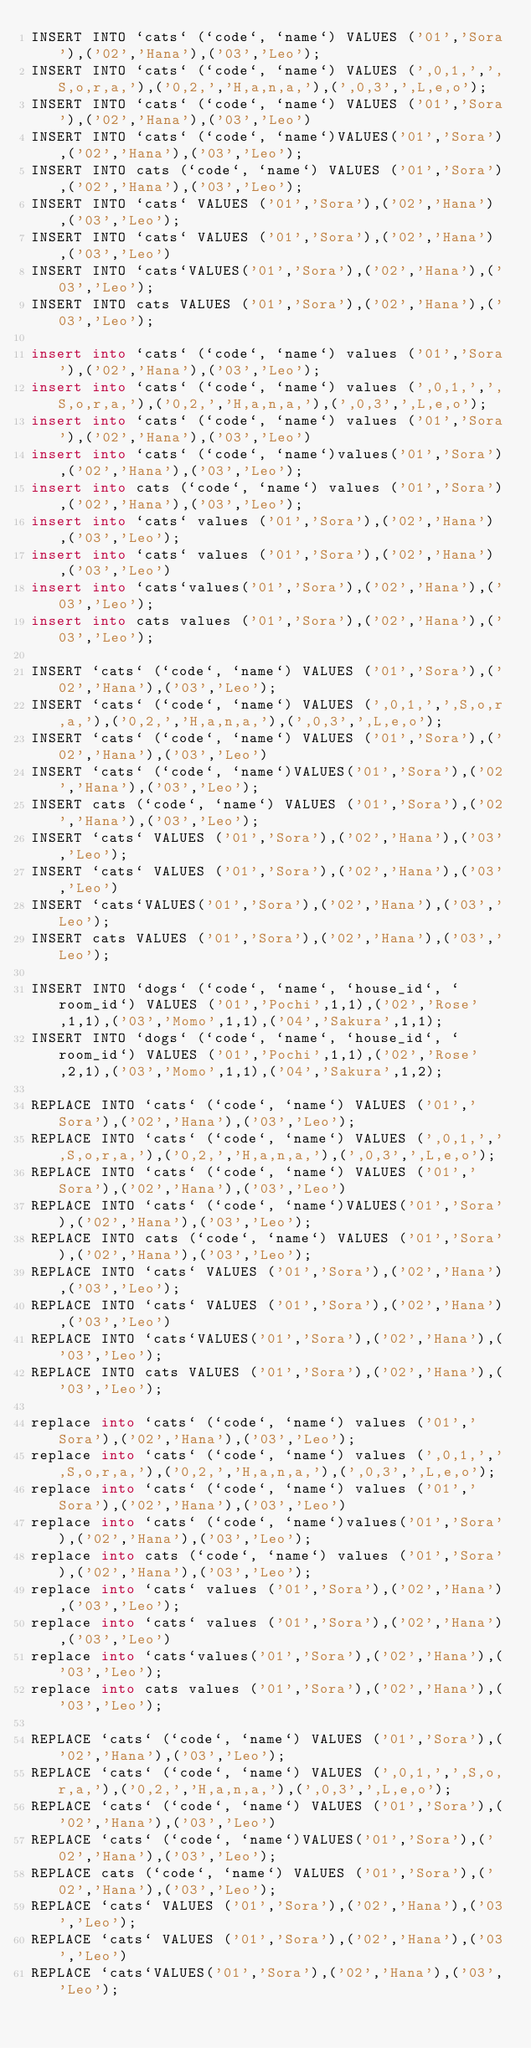Convert code to text. <code><loc_0><loc_0><loc_500><loc_500><_SQL_>INSERT INTO `cats` (`code`, `name`) VALUES ('01','Sora'),('02','Hana'),('03','Leo');
INSERT INTO `cats` (`code`, `name`) VALUES (',0,1,',',S,o,r,a,'),('0,2,','H,a,n,a,'),(',0,3',',L,e,o');
INSERT INTO `cats` (`code`, `name`) VALUES ('01','Sora'),('02','Hana'),('03','Leo')
INSERT INTO `cats` (`code`, `name`)VALUES('01','Sora'),('02','Hana'),('03','Leo');
INSERT INTO cats (`code`, `name`) VALUES ('01','Sora'),('02','Hana'),('03','Leo');
INSERT INTO `cats` VALUES ('01','Sora'),('02','Hana'),('03','Leo');
INSERT INTO `cats` VALUES ('01','Sora'),('02','Hana'),('03','Leo')
INSERT INTO `cats`VALUES('01','Sora'),('02','Hana'),('03','Leo');
INSERT INTO cats VALUES ('01','Sora'),('02','Hana'),('03','Leo');

insert into `cats` (`code`, `name`) values ('01','Sora'),('02','Hana'),('03','Leo');
insert into `cats` (`code`, `name`) values (',0,1,',',S,o,r,a,'),('0,2,','H,a,n,a,'),(',0,3',',L,e,o');
insert into `cats` (`code`, `name`) values ('01','Sora'),('02','Hana'),('03','Leo')
insert into `cats` (`code`, `name`)values('01','Sora'),('02','Hana'),('03','Leo');
insert into cats (`code`, `name`) values ('01','Sora'),('02','Hana'),('03','Leo');
insert into `cats` values ('01','Sora'),('02','Hana'),('03','Leo');
insert into `cats` values ('01','Sora'),('02','Hana'),('03','Leo')
insert into `cats`values('01','Sora'),('02','Hana'),('03','Leo');
insert into cats values ('01','Sora'),('02','Hana'),('03','Leo');

INSERT `cats` (`code`, `name`) VALUES ('01','Sora'),('02','Hana'),('03','Leo');
INSERT `cats` (`code`, `name`) VALUES (',0,1,',',S,o,r,a,'),('0,2,','H,a,n,a,'),(',0,3',',L,e,o');
INSERT `cats` (`code`, `name`) VALUES ('01','Sora'),('02','Hana'),('03','Leo')
INSERT `cats` (`code`, `name`)VALUES('01','Sora'),('02','Hana'),('03','Leo');
INSERT cats (`code`, `name`) VALUES ('01','Sora'),('02','Hana'),('03','Leo');
INSERT `cats` VALUES ('01','Sora'),('02','Hana'),('03','Leo');
INSERT `cats` VALUES ('01','Sora'),('02','Hana'),('03','Leo')
INSERT `cats`VALUES('01','Sora'),('02','Hana'),('03','Leo');
INSERT cats VALUES ('01','Sora'),('02','Hana'),('03','Leo');

INSERT INTO `dogs` (`code`, `name`, `house_id`, `room_id`) VALUES ('01','Pochi',1,1),('02','Rose',1,1),('03','Momo',1,1),('04','Sakura',1,1);
INSERT INTO `dogs` (`code`, `name`, `house_id`, `room_id`) VALUES ('01','Pochi',1,1),('02','Rose',2,1),('03','Momo',1,1),('04','Sakura',1,2);

REPLACE INTO `cats` (`code`, `name`) VALUES ('01','Sora'),('02','Hana'),('03','Leo');
REPLACE INTO `cats` (`code`, `name`) VALUES (',0,1,',',S,o,r,a,'),('0,2,','H,a,n,a,'),(',0,3',',L,e,o');
REPLACE INTO `cats` (`code`, `name`) VALUES ('01','Sora'),('02','Hana'),('03','Leo')
REPLACE INTO `cats` (`code`, `name`)VALUES('01','Sora'),('02','Hana'),('03','Leo');
REPLACE INTO cats (`code`, `name`) VALUES ('01','Sora'),('02','Hana'),('03','Leo');
REPLACE INTO `cats` VALUES ('01','Sora'),('02','Hana'),('03','Leo');
REPLACE INTO `cats` VALUES ('01','Sora'),('02','Hana'),('03','Leo')
REPLACE INTO `cats`VALUES('01','Sora'),('02','Hana'),('03','Leo');
REPLACE INTO cats VALUES ('01','Sora'),('02','Hana'),('03','Leo');

replace into `cats` (`code`, `name`) values ('01','Sora'),('02','Hana'),('03','Leo');
replace into `cats` (`code`, `name`) values (',0,1,',',S,o,r,a,'),('0,2,','H,a,n,a,'),(',0,3',',L,e,o');
replace into `cats` (`code`, `name`) values ('01','Sora'),('02','Hana'),('03','Leo')
replace into `cats` (`code`, `name`)values('01','Sora'),('02','Hana'),('03','Leo');
replace into cats (`code`, `name`) values ('01','Sora'),('02','Hana'),('03','Leo');
replace into `cats` values ('01','Sora'),('02','Hana'),('03','Leo');
replace into `cats` values ('01','Sora'),('02','Hana'),('03','Leo')
replace into `cats`values('01','Sora'),('02','Hana'),('03','Leo');
replace into cats values ('01','Sora'),('02','Hana'),('03','Leo');

REPLACE `cats` (`code`, `name`) VALUES ('01','Sora'),('02','Hana'),('03','Leo');
REPLACE `cats` (`code`, `name`) VALUES (',0,1,',',S,o,r,a,'),('0,2,','H,a,n,a,'),(',0,3',',L,e,o');
REPLACE `cats` (`code`, `name`) VALUES ('01','Sora'),('02','Hana'),('03','Leo')
REPLACE `cats` (`code`, `name`)VALUES('01','Sora'),('02','Hana'),('03','Leo');
REPLACE cats (`code`, `name`) VALUES ('01','Sora'),('02','Hana'),('03','Leo');
REPLACE `cats` VALUES ('01','Sora'),('02','Hana'),('03','Leo');
REPLACE `cats` VALUES ('01','Sora'),('02','Hana'),('03','Leo')
REPLACE `cats`VALUES('01','Sora'),('02','Hana'),('03','Leo');</code> 